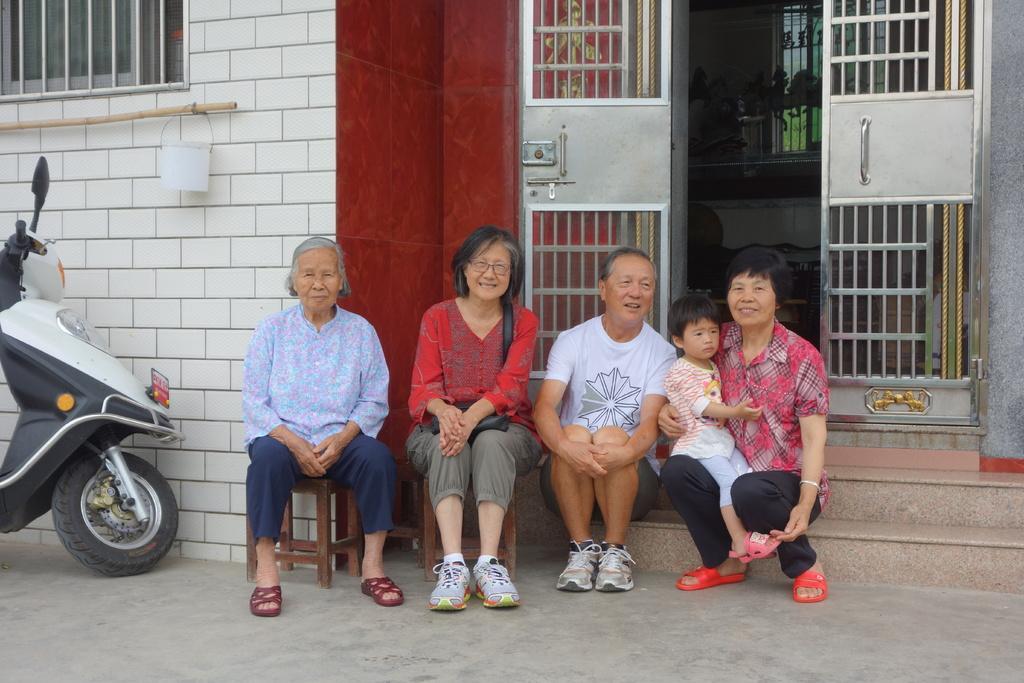Describe this image in one or two sentences. In this image we can see people sitting. In the background of the image there is a house, door, window. To the left side of the image there is a vehicle. At the bottom of the image there is floor. 